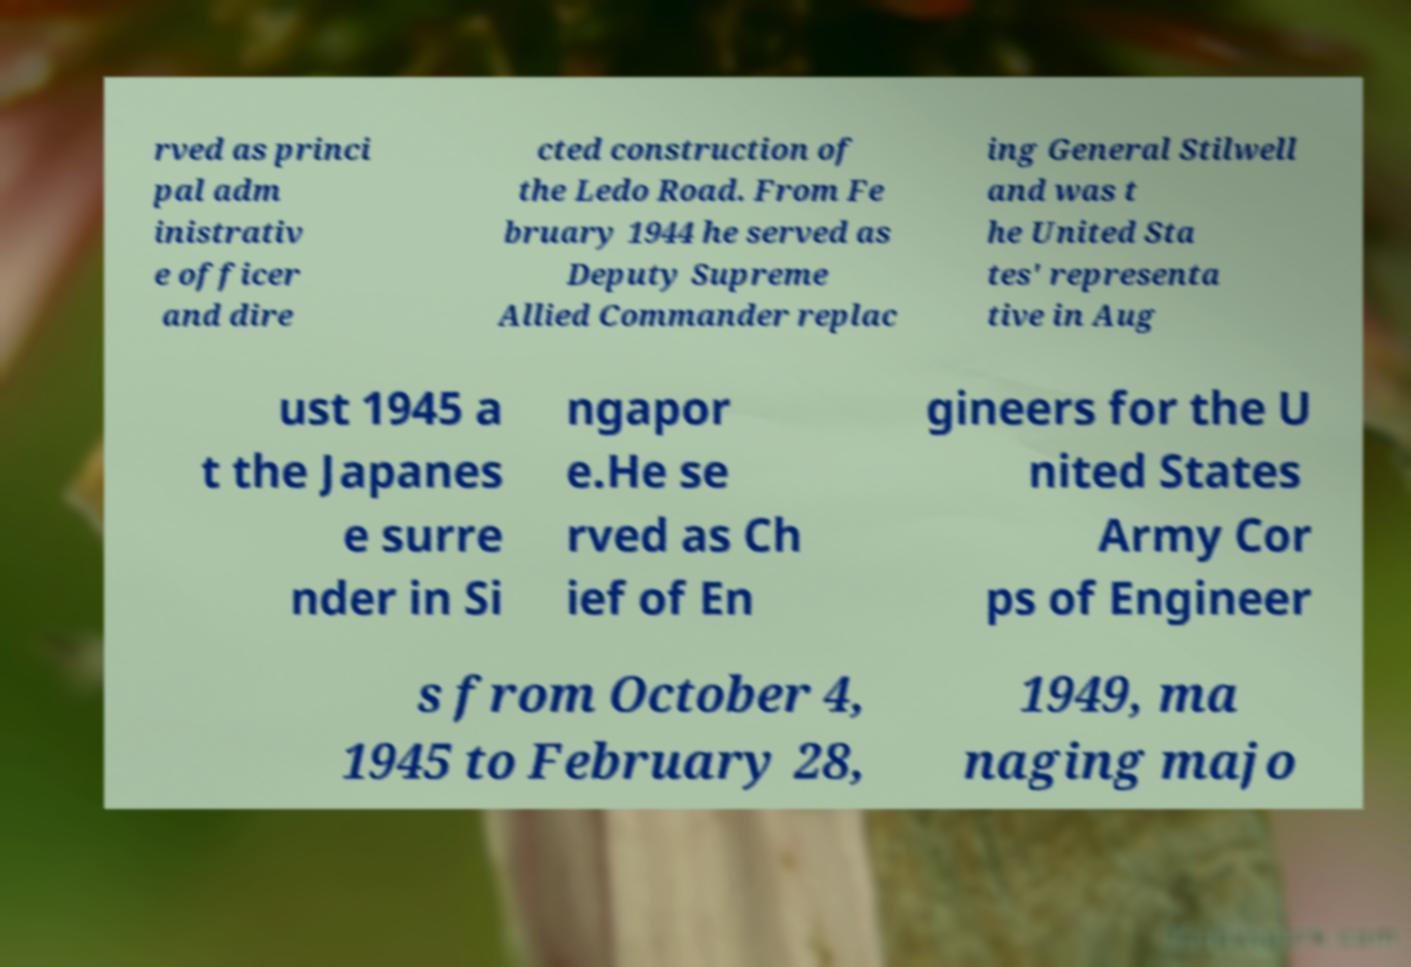Can you accurately transcribe the text from the provided image for me? rved as princi pal adm inistrativ e officer and dire cted construction of the Ledo Road. From Fe bruary 1944 he served as Deputy Supreme Allied Commander replac ing General Stilwell and was t he United Sta tes' representa tive in Aug ust 1945 a t the Japanes e surre nder in Si ngapor e.He se rved as Ch ief of En gineers for the U nited States Army Cor ps of Engineer s from October 4, 1945 to February 28, 1949, ma naging majo 